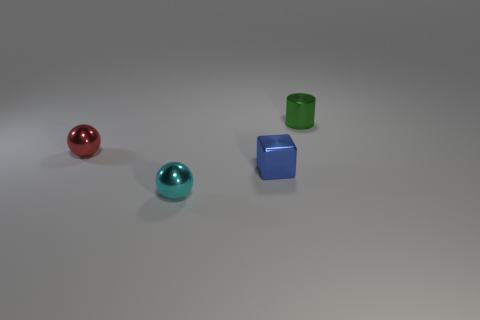Add 4 small red things. How many objects exist? 8 Subtract all blocks. How many objects are left? 3 Add 4 small green cylinders. How many small green cylinders are left? 5 Add 4 blue metallic objects. How many blue metallic objects exist? 5 Subtract 1 blue blocks. How many objects are left? 3 Subtract all small blue metallic cubes. Subtract all tiny red balls. How many objects are left? 2 